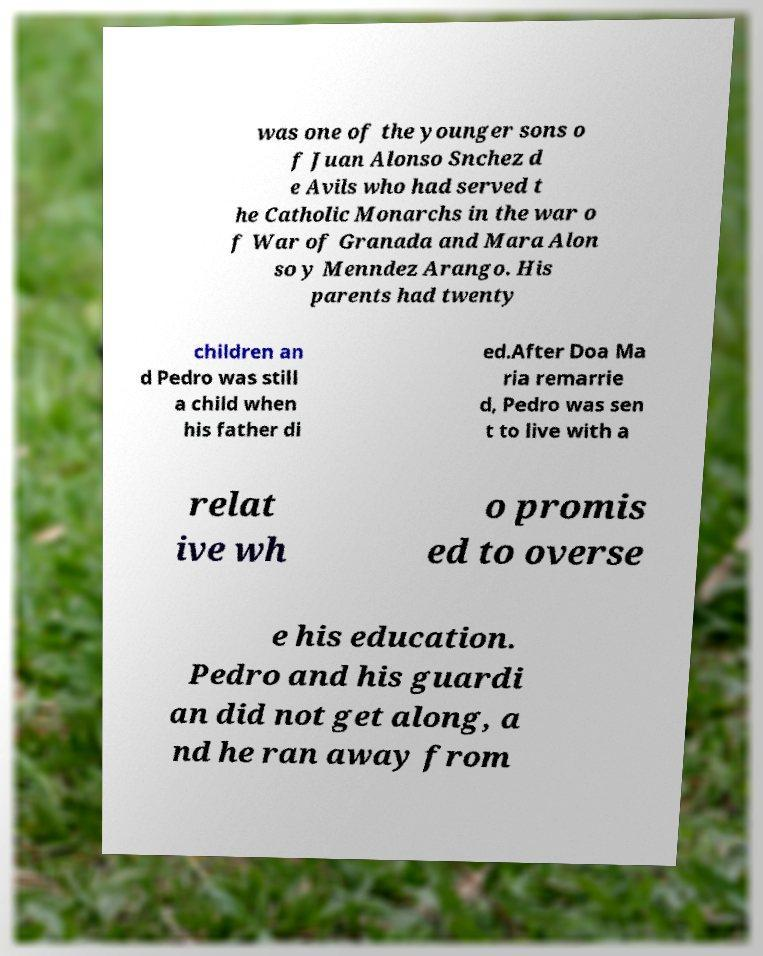Please read and relay the text visible in this image. What does it say? was one of the younger sons o f Juan Alonso Snchez d e Avils who had served t he Catholic Monarchs in the war o f War of Granada and Mara Alon so y Menndez Arango. His parents had twenty children an d Pedro was still a child when his father di ed.After Doa Ma ria remarrie d, Pedro was sen t to live with a relat ive wh o promis ed to overse e his education. Pedro and his guardi an did not get along, a nd he ran away from 